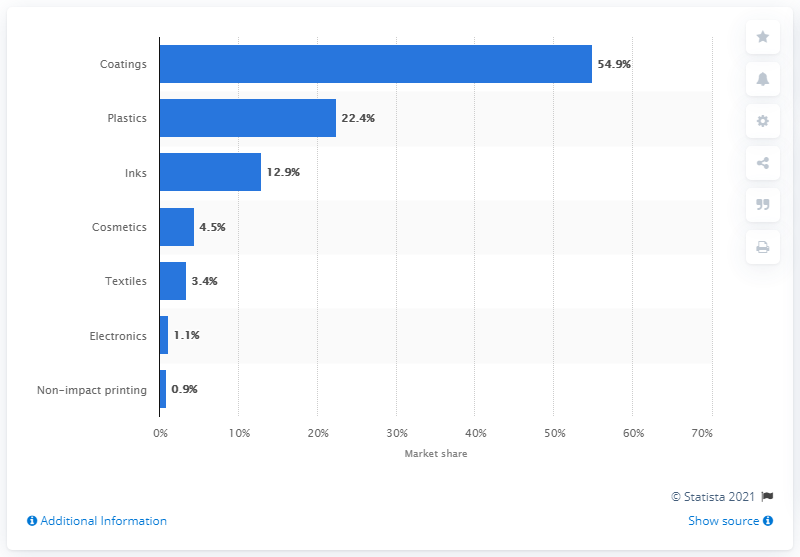Indicate a few pertinent items in this graphic. In 2016, coatings accounted for 54.9% of the market. 